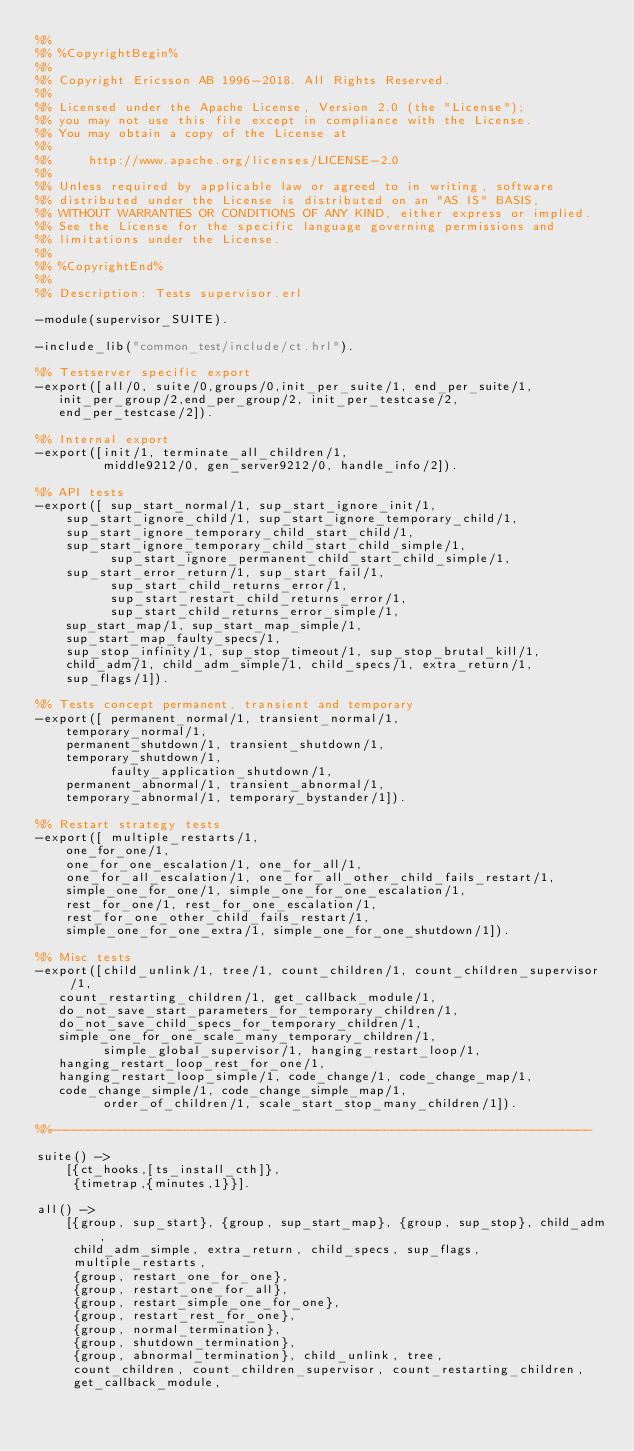<code> <loc_0><loc_0><loc_500><loc_500><_Erlang_>%%
%% %CopyrightBegin%
%%
%% Copyright Ericsson AB 1996-2018. All Rights Reserved.
%%
%% Licensed under the Apache License, Version 2.0 (the "License");
%% you may not use this file except in compliance with the License.
%% You may obtain a copy of the License at
%%
%%     http://www.apache.org/licenses/LICENSE-2.0
%%
%% Unless required by applicable law or agreed to in writing, software
%% distributed under the License is distributed on an "AS IS" BASIS,
%% WITHOUT WARRANTIES OR CONDITIONS OF ANY KIND, either express or implied.
%% See the License for the specific language governing permissions and
%% limitations under the License.
%%
%% %CopyrightEnd%
%%
%% Description: Tests supervisor.erl

-module(supervisor_SUITE).

-include_lib("common_test/include/ct.hrl").

%% Testserver specific export
-export([all/0, suite/0,groups/0,init_per_suite/1, end_per_suite/1, 
	 init_per_group/2,end_per_group/2, init_per_testcase/2,
	 end_per_testcase/2]).

%% Internal export
-export([init/1, terminate_all_children/1,
         middle9212/0, gen_server9212/0, handle_info/2]).

%% API tests
-export([ sup_start_normal/1, sup_start_ignore_init/1, 
	  sup_start_ignore_child/1, sup_start_ignore_temporary_child/1,
	  sup_start_ignore_temporary_child_start_child/1,
	  sup_start_ignore_temporary_child_start_child_simple/1,
          sup_start_ignore_permanent_child_start_child_simple/1,
	  sup_start_error_return/1, sup_start_fail/1,
          sup_start_child_returns_error/1,
          sup_start_restart_child_returns_error/1,
          sup_start_child_returns_error_simple/1,
	  sup_start_map/1, sup_start_map_simple/1,
	  sup_start_map_faulty_specs/1,
	  sup_stop_infinity/1, sup_stop_timeout/1, sup_stop_brutal_kill/1,
	  child_adm/1, child_adm_simple/1, child_specs/1, extra_return/1,
	  sup_flags/1]).

%% Tests concept permanent, transient and temporary 
-export([ permanent_normal/1, transient_normal/1,
	  temporary_normal/1,
	  permanent_shutdown/1, transient_shutdown/1,
	  temporary_shutdown/1,
          faulty_application_shutdown/1,
	  permanent_abnormal/1, transient_abnormal/1,
	  temporary_abnormal/1, temporary_bystander/1]).

%% Restart strategy tests 
-export([ multiple_restarts/1,
	  one_for_one/1,
	  one_for_one_escalation/1, one_for_all/1,
	  one_for_all_escalation/1, one_for_all_other_child_fails_restart/1,
	  simple_one_for_one/1, simple_one_for_one_escalation/1,
	  rest_for_one/1, rest_for_one_escalation/1,
	  rest_for_one_other_child_fails_restart/1,
	  simple_one_for_one_extra/1, simple_one_for_one_shutdown/1]).

%% Misc tests
-export([child_unlink/1, tree/1, count_children/1, count_children_supervisor/1,
	 count_restarting_children/1, get_callback_module/1,
	 do_not_save_start_parameters_for_temporary_children/1,
	 do_not_save_child_specs_for_temporary_children/1,
	 simple_one_for_one_scale_many_temporary_children/1,
         simple_global_supervisor/1, hanging_restart_loop/1,
	 hanging_restart_loop_rest_for_one/1,
	 hanging_restart_loop_simple/1, code_change/1, code_change_map/1,
	 code_change_simple/1, code_change_simple_map/1,
         order_of_children/1, scale_start_stop_many_children/1]).

%%-------------------------------------------------------------------------

suite() ->
    [{ct_hooks,[ts_install_cth]},
     {timetrap,{minutes,1}}].

all() -> 
    [{group, sup_start}, {group, sup_start_map}, {group, sup_stop}, child_adm,
     child_adm_simple, extra_return, child_specs, sup_flags,
     multiple_restarts,
     {group, restart_one_for_one},
     {group, restart_one_for_all},
     {group, restart_simple_one_for_one},
     {group, restart_rest_for_one},
     {group, normal_termination},
     {group, shutdown_termination},
     {group, abnormal_termination}, child_unlink, tree,
     count_children, count_children_supervisor, count_restarting_children,
     get_callback_module,</code> 